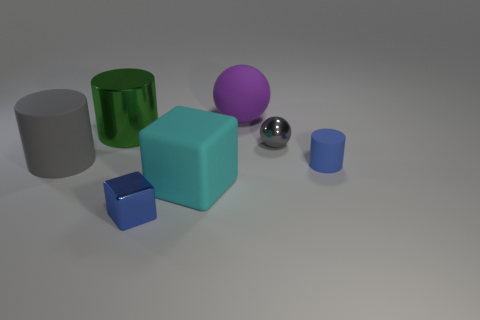What shapes are visible in the image? The image shows a variety of geometric shapes: there's a cylinder, a sphere, and cubes in different sizes. They provide an interesting study in geometry and spatial arrangement. 